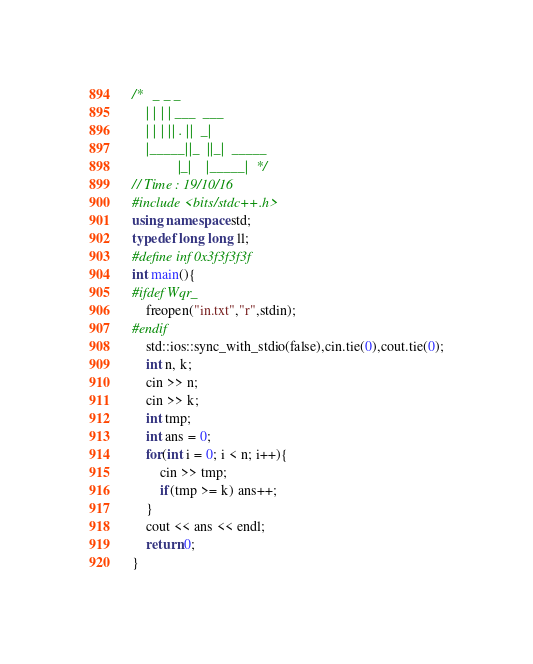Convert code to text. <code><loc_0><loc_0><loc_500><loc_500><_C++_>/*   _ _ _                     
    | | | | ___  ___           
    | | | || . ||  _|          
    |_____||_  ||_|  _____     
             |_|    |_____|  */
// Time : 19/10/16
#include <bits/stdc++.h>
using namespace std;
typedef long long ll;
#define inf 0x3f3f3f3f
int main(){
#ifdef Wqr_
    freopen("in.txt","r",stdin);
#endif
    std::ios::sync_with_stdio(false),cin.tie(0),cout.tie(0);
    int n, k;
    cin >> n;
    cin >> k;
    int tmp;
    int ans = 0;
    for(int i = 0; i < n; i++){
        cin >> tmp;
        if(tmp >= k) ans++;
    }
    cout << ans << endl;
    return 0;
}</code> 